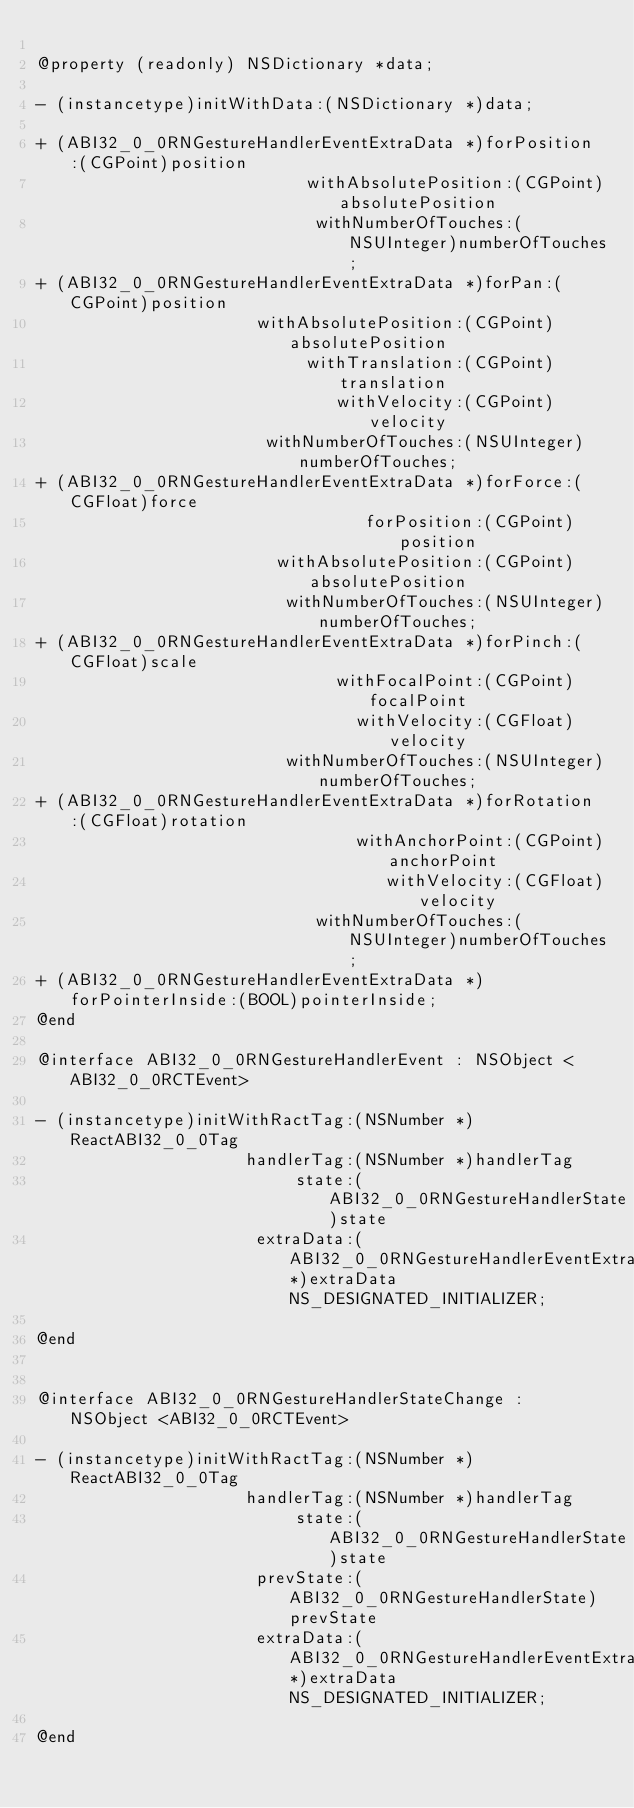Convert code to text. <code><loc_0><loc_0><loc_500><loc_500><_C_>
@property (readonly) NSDictionary *data;

- (instancetype)initWithData:(NSDictionary *)data;

+ (ABI32_0_0RNGestureHandlerEventExtraData *)forPosition:(CGPoint)position
                           withAbsolutePosition:(CGPoint)absolutePosition
                            withNumberOfTouches:(NSUInteger)numberOfTouches;
+ (ABI32_0_0RNGestureHandlerEventExtraData *)forPan:(CGPoint)position
                      withAbsolutePosition:(CGPoint)absolutePosition
                           withTranslation:(CGPoint)translation
                              withVelocity:(CGPoint)velocity
                       withNumberOfTouches:(NSUInteger)numberOfTouches;
+ (ABI32_0_0RNGestureHandlerEventExtraData *)forForce:(CGFloat)force
                                 forPosition:(CGPoint)position
                        withAbsolutePosition:(CGPoint)absolutePosition
                         withNumberOfTouches:(NSUInteger)numberOfTouches;
+ (ABI32_0_0RNGestureHandlerEventExtraData *)forPinch:(CGFloat)scale
                              withFocalPoint:(CGPoint)focalPoint
                                withVelocity:(CGFloat)velocity
                         withNumberOfTouches:(NSUInteger)numberOfTouches;
+ (ABI32_0_0RNGestureHandlerEventExtraData *)forRotation:(CGFloat)rotation
                                withAnchorPoint:(CGPoint)anchorPoint
                                   withVelocity:(CGFloat)velocity
                            withNumberOfTouches:(NSUInteger)numberOfTouches;
+ (ABI32_0_0RNGestureHandlerEventExtraData *)forPointerInside:(BOOL)pointerInside;
@end

@interface ABI32_0_0RNGestureHandlerEvent : NSObject <ABI32_0_0RCTEvent>

- (instancetype)initWithRactTag:(NSNumber *)ReactABI32_0_0Tag
                     handlerTag:(NSNumber *)handlerTag
                          state:(ABI32_0_0RNGestureHandlerState)state
                      extraData:(ABI32_0_0RNGestureHandlerEventExtraData*)extraData NS_DESIGNATED_INITIALIZER;

@end


@interface ABI32_0_0RNGestureHandlerStateChange : NSObject <ABI32_0_0RCTEvent>

- (instancetype)initWithRactTag:(NSNumber *)ReactABI32_0_0Tag
                     handlerTag:(NSNumber *)handlerTag
                          state:(ABI32_0_0RNGestureHandlerState)state
                      prevState:(ABI32_0_0RNGestureHandlerState)prevState
                      extraData:(ABI32_0_0RNGestureHandlerEventExtraData*)extraData NS_DESIGNATED_INITIALIZER;

@end
</code> 